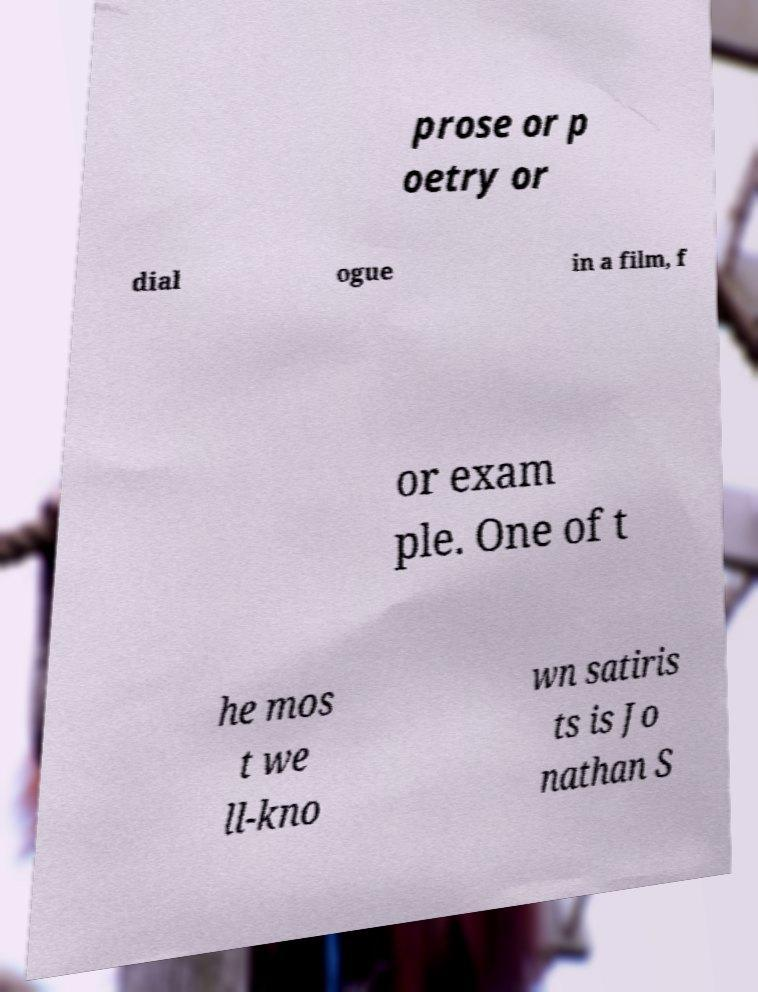I need the written content from this picture converted into text. Can you do that? prose or p oetry or dial ogue in a film, f or exam ple. One of t he mos t we ll-kno wn satiris ts is Jo nathan S 